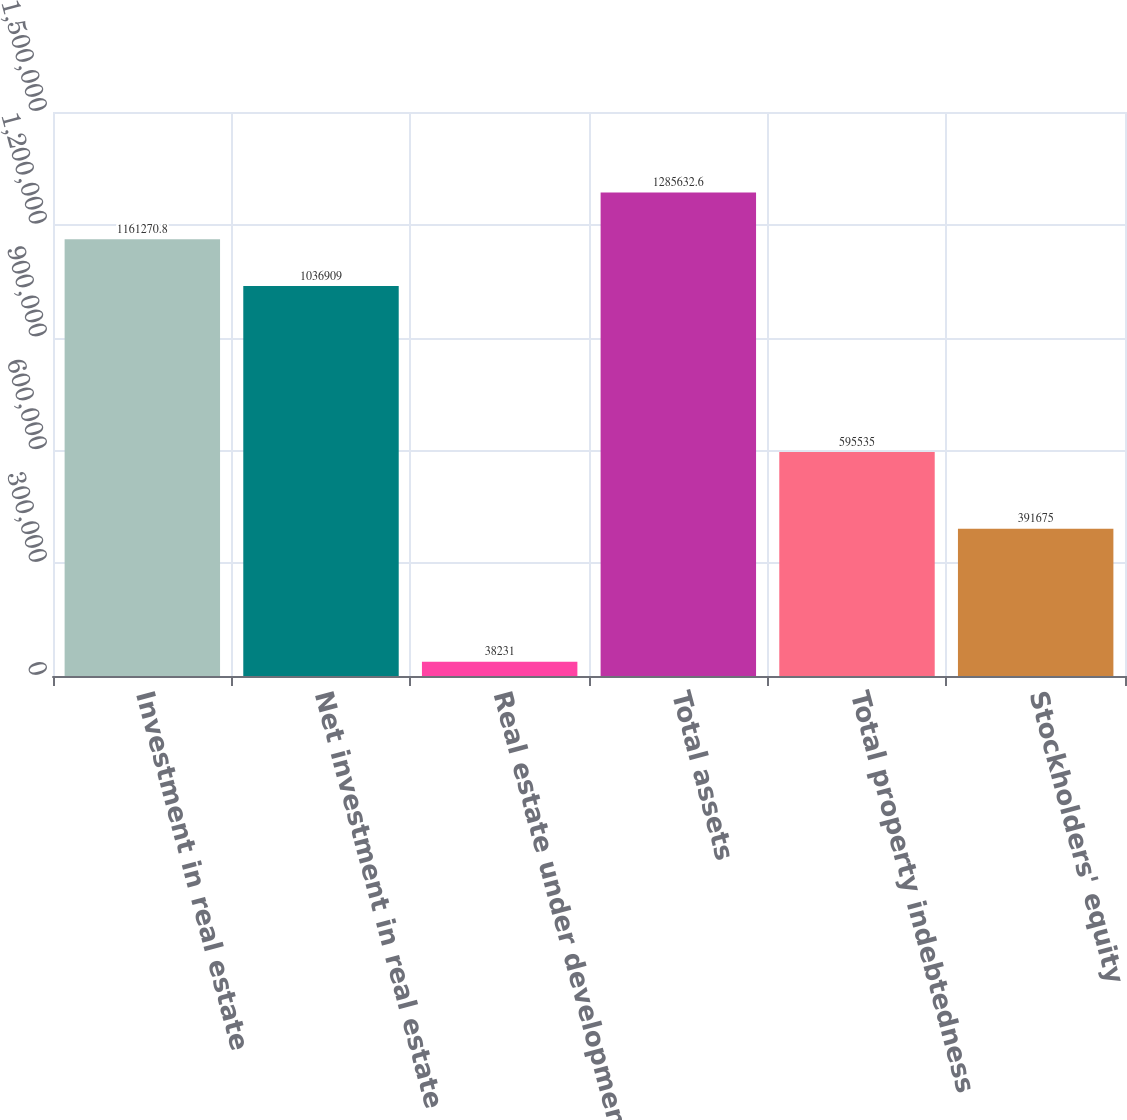<chart> <loc_0><loc_0><loc_500><loc_500><bar_chart><fcel>Investment in real estate<fcel>Net investment in real estate<fcel>Real estate under development<fcel>Total assets<fcel>Total property indebtedness<fcel>Stockholders' equity<nl><fcel>1.16127e+06<fcel>1.03691e+06<fcel>38231<fcel>1.28563e+06<fcel>595535<fcel>391675<nl></chart> 